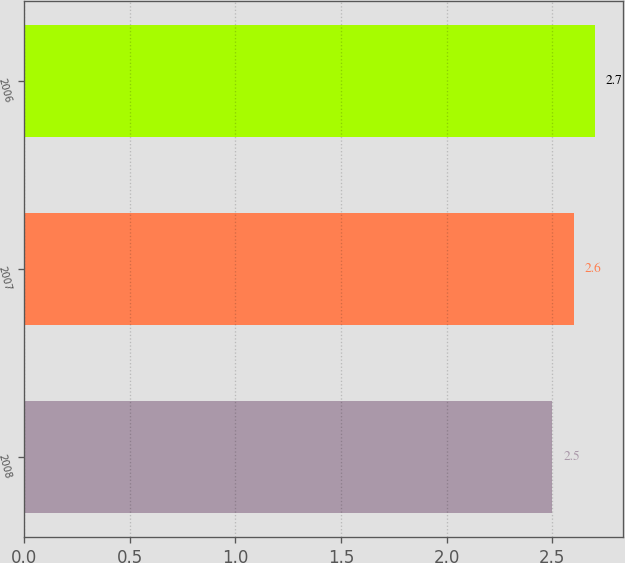Convert chart. <chart><loc_0><loc_0><loc_500><loc_500><bar_chart><fcel>2008<fcel>2007<fcel>2006<nl><fcel>2.5<fcel>2.6<fcel>2.7<nl></chart> 